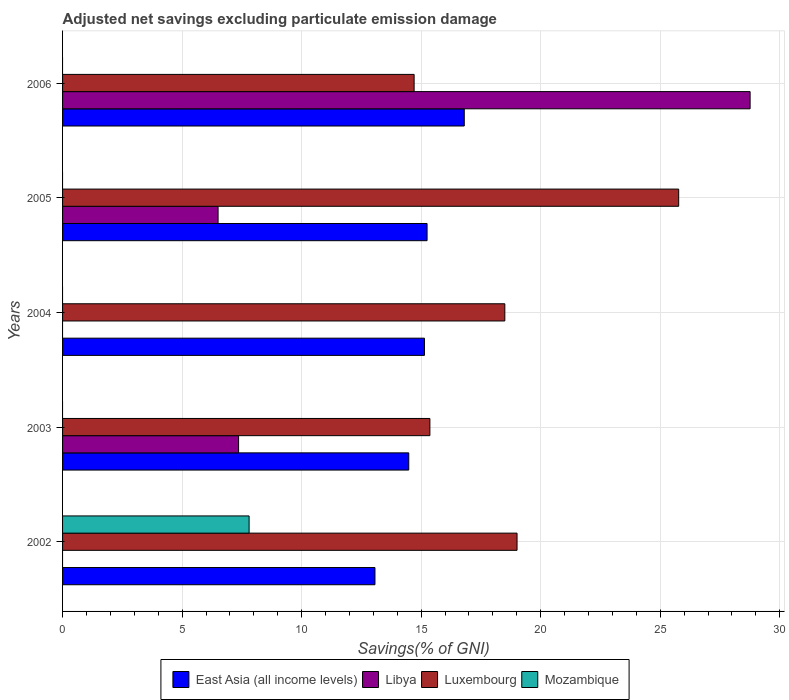How many different coloured bars are there?
Your answer should be compact. 4. How many groups of bars are there?
Your answer should be very brief. 5. Are the number of bars per tick equal to the number of legend labels?
Offer a very short reply. No. How many bars are there on the 3rd tick from the top?
Offer a terse response. 2. How many bars are there on the 4th tick from the bottom?
Your response must be concise. 3. In how many cases, is the number of bars for a given year not equal to the number of legend labels?
Your response must be concise. 5. What is the adjusted net savings in Mozambique in 2002?
Your answer should be very brief. 7.8. Across all years, what is the maximum adjusted net savings in Luxembourg?
Offer a terse response. 25.77. Across all years, what is the minimum adjusted net savings in Mozambique?
Offer a very short reply. 0. In which year was the adjusted net savings in Luxembourg maximum?
Offer a terse response. 2005. What is the total adjusted net savings in East Asia (all income levels) in the graph?
Offer a terse response. 74.74. What is the difference between the adjusted net savings in Libya in 2003 and that in 2006?
Give a very brief answer. -21.4. What is the difference between the adjusted net savings in Luxembourg in 2005 and the adjusted net savings in Libya in 2002?
Your answer should be compact. 25.77. What is the average adjusted net savings in East Asia (all income levels) per year?
Give a very brief answer. 14.95. In the year 2003, what is the difference between the adjusted net savings in East Asia (all income levels) and adjusted net savings in Luxembourg?
Give a very brief answer. -0.88. What is the ratio of the adjusted net savings in East Asia (all income levels) in 2005 to that in 2006?
Your answer should be compact. 0.91. Is the adjusted net savings in East Asia (all income levels) in 2003 less than that in 2004?
Make the answer very short. Yes. Is the difference between the adjusted net savings in East Asia (all income levels) in 2005 and 2006 greater than the difference between the adjusted net savings in Luxembourg in 2005 and 2006?
Make the answer very short. No. What is the difference between the highest and the second highest adjusted net savings in Libya?
Provide a short and direct response. 21.4. What is the difference between the highest and the lowest adjusted net savings in East Asia (all income levels)?
Your response must be concise. 3.74. Is the sum of the adjusted net savings in East Asia (all income levels) in 2003 and 2005 greater than the maximum adjusted net savings in Luxembourg across all years?
Your response must be concise. Yes. Is it the case that in every year, the sum of the adjusted net savings in East Asia (all income levels) and adjusted net savings in Luxembourg is greater than the adjusted net savings in Libya?
Keep it short and to the point. Yes. How many bars are there?
Offer a very short reply. 14. Are all the bars in the graph horizontal?
Provide a short and direct response. Yes. What is the difference between two consecutive major ticks on the X-axis?
Your response must be concise. 5. Does the graph contain any zero values?
Make the answer very short. Yes. Where does the legend appear in the graph?
Give a very brief answer. Bottom center. How are the legend labels stacked?
Your response must be concise. Horizontal. What is the title of the graph?
Keep it short and to the point. Adjusted net savings excluding particulate emission damage. Does "Gambia, The" appear as one of the legend labels in the graph?
Offer a terse response. No. What is the label or title of the X-axis?
Keep it short and to the point. Savings(% of GNI). What is the Savings(% of GNI) of East Asia (all income levels) in 2002?
Offer a terse response. 13.07. What is the Savings(% of GNI) in Libya in 2002?
Ensure brevity in your answer.  0. What is the Savings(% of GNI) in Luxembourg in 2002?
Keep it short and to the point. 19.01. What is the Savings(% of GNI) in Mozambique in 2002?
Offer a terse response. 7.8. What is the Savings(% of GNI) of East Asia (all income levels) in 2003?
Keep it short and to the point. 14.48. What is the Savings(% of GNI) of Libya in 2003?
Keep it short and to the point. 7.36. What is the Savings(% of GNI) in Luxembourg in 2003?
Ensure brevity in your answer.  15.36. What is the Savings(% of GNI) of Mozambique in 2003?
Your answer should be very brief. 0. What is the Savings(% of GNI) of East Asia (all income levels) in 2004?
Your answer should be very brief. 15.14. What is the Savings(% of GNI) of Libya in 2004?
Provide a short and direct response. 0. What is the Savings(% of GNI) of Luxembourg in 2004?
Ensure brevity in your answer.  18.5. What is the Savings(% of GNI) of East Asia (all income levels) in 2005?
Your response must be concise. 15.25. What is the Savings(% of GNI) of Libya in 2005?
Your response must be concise. 6.51. What is the Savings(% of GNI) in Luxembourg in 2005?
Provide a short and direct response. 25.77. What is the Savings(% of GNI) in East Asia (all income levels) in 2006?
Ensure brevity in your answer.  16.8. What is the Savings(% of GNI) of Libya in 2006?
Your answer should be compact. 28.76. What is the Savings(% of GNI) in Luxembourg in 2006?
Your response must be concise. 14.71. Across all years, what is the maximum Savings(% of GNI) in East Asia (all income levels)?
Ensure brevity in your answer.  16.8. Across all years, what is the maximum Savings(% of GNI) of Libya?
Ensure brevity in your answer.  28.76. Across all years, what is the maximum Savings(% of GNI) of Luxembourg?
Provide a short and direct response. 25.77. Across all years, what is the maximum Savings(% of GNI) of Mozambique?
Your answer should be compact. 7.8. Across all years, what is the minimum Savings(% of GNI) in East Asia (all income levels)?
Provide a short and direct response. 13.07. Across all years, what is the minimum Savings(% of GNI) in Libya?
Make the answer very short. 0. Across all years, what is the minimum Savings(% of GNI) of Luxembourg?
Offer a terse response. 14.71. Across all years, what is the minimum Savings(% of GNI) in Mozambique?
Provide a short and direct response. 0. What is the total Savings(% of GNI) of East Asia (all income levels) in the graph?
Keep it short and to the point. 74.74. What is the total Savings(% of GNI) of Libya in the graph?
Offer a terse response. 42.63. What is the total Savings(% of GNI) of Luxembourg in the graph?
Offer a very short reply. 93.35. What is the total Savings(% of GNI) in Mozambique in the graph?
Offer a very short reply. 7.8. What is the difference between the Savings(% of GNI) in East Asia (all income levels) in 2002 and that in 2003?
Keep it short and to the point. -1.41. What is the difference between the Savings(% of GNI) in Luxembourg in 2002 and that in 2003?
Offer a terse response. 3.65. What is the difference between the Savings(% of GNI) in East Asia (all income levels) in 2002 and that in 2004?
Make the answer very short. -2.07. What is the difference between the Savings(% of GNI) of Luxembourg in 2002 and that in 2004?
Your answer should be very brief. 0.51. What is the difference between the Savings(% of GNI) in East Asia (all income levels) in 2002 and that in 2005?
Provide a succinct answer. -2.18. What is the difference between the Savings(% of GNI) in Luxembourg in 2002 and that in 2005?
Your answer should be compact. -6.76. What is the difference between the Savings(% of GNI) in East Asia (all income levels) in 2002 and that in 2006?
Make the answer very short. -3.74. What is the difference between the Savings(% of GNI) of Luxembourg in 2002 and that in 2006?
Offer a terse response. 4.31. What is the difference between the Savings(% of GNI) of East Asia (all income levels) in 2003 and that in 2004?
Keep it short and to the point. -0.66. What is the difference between the Savings(% of GNI) of Luxembourg in 2003 and that in 2004?
Your response must be concise. -3.13. What is the difference between the Savings(% of GNI) of East Asia (all income levels) in 2003 and that in 2005?
Your answer should be very brief. -0.77. What is the difference between the Savings(% of GNI) in Libya in 2003 and that in 2005?
Provide a short and direct response. 0.86. What is the difference between the Savings(% of GNI) in Luxembourg in 2003 and that in 2005?
Make the answer very short. -10.41. What is the difference between the Savings(% of GNI) of East Asia (all income levels) in 2003 and that in 2006?
Provide a short and direct response. -2.32. What is the difference between the Savings(% of GNI) in Libya in 2003 and that in 2006?
Give a very brief answer. -21.4. What is the difference between the Savings(% of GNI) in Luxembourg in 2003 and that in 2006?
Keep it short and to the point. 0.66. What is the difference between the Savings(% of GNI) of East Asia (all income levels) in 2004 and that in 2005?
Give a very brief answer. -0.11. What is the difference between the Savings(% of GNI) in Luxembourg in 2004 and that in 2005?
Offer a very short reply. -7.27. What is the difference between the Savings(% of GNI) in East Asia (all income levels) in 2004 and that in 2006?
Keep it short and to the point. -1.66. What is the difference between the Savings(% of GNI) of Luxembourg in 2004 and that in 2006?
Offer a terse response. 3.79. What is the difference between the Savings(% of GNI) of East Asia (all income levels) in 2005 and that in 2006?
Make the answer very short. -1.56. What is the difference between the Savings(% of GNI) in Libya in 2005 and that in 2006?
Keep it short and to the point. -22.25. What is the difference between the Savings(% of GNI) of Luxembourg in 2005 and that in 2006?
Make the answer very short. 11.07. What is the difference between the Savings(% of GNI) in East Asia (all income levels) in 2002 and the Savings(% of GNI) in Libya in 2003?
Offer a very short reply. 5.7. What is the difference between the Savings(% of GNI) of East Asia (all income levels) in 2002 and the Savings(% of GNI) of Luxembourg in 2003?
Provide a succinct answer. -2.3. What is the difference between the Savings(% of GNI) of East Asia (all income levels) in 2002 and the Savings(% of GNI) of Luxembourg in 2004?
Give a very brief answer. -5.43. What is the difference between the Savings(% of GNI) of East Asia (all income levels) in 2002 and the Savings(% of GNI) of Libya in 2005?
Ensure brevity in your answer.  6.56. What is the difference between the Savings(% of GNI) of East Asia (all income levels) in 2002 and the Savings(% of GNI) of Luxembourg in 2005?
Give a very brief answer. -12.7. What is the difference between the Savings(% of GNI) in East Asia (all income levels) in 2002 and the Savings(% of GNI) in Libya in 2006?
Keep it short and to the point. -15.69. What is the difference between the Savings(% of GNI) in East Asia (all income levels) in 2002 and the Savings(% of GNI) in Luxembourg in 2006?
Keep it short and to the point. -1.64. What is the difference between the Savings(% of GNI) of East Asia (all income levels) in 2003 and the Savings(% of GNI) of Luxembourg in 2004?
Make the answer very short. -4.02. What is the difference between the Savings(% of GNI) of Libya in 2003 and the Savings(% of GNI) of Luxembourg in 2004?
Your response must be concise. -11.14. What is the difference between the Savings(% of GNI) in East Asia (all income levels) in 2003 and the Savings(% of GNI) in Libya in 2005?
Offer a terse response. 7.98. What is the difference between the Savings(% of GNI) of East Asia (all income levels) in 2003 and the Savings(% of GNI) of Luxembourg in 2005?
Your answer should be very brief. -11.29. What is the difference between the Savings(% of GNI) of Libya in 2003 and the Savings(% of GNI) of Luxembourg in 2005?
Keep it short and to the point. -18.41. What is the difference between the Savings(% of GNI) in East Asia (all income levels) in 2003 and the Savings(% of GNI) in Libya in 2006?
Ensure brevity in your answer.  -14.28. What is the difference between the Savings(% of GNI) of East Asia (all income levels) in 2003 and the Savings(% of GNI) of Luxembourg in 2006?
Your response must be concise. -0.22. What is the difference between the Savings(% of GNI) in Libya in 2003 and the Savings(% of GNI) in Luxembourg in 2006?
Keep it short and to the point. -7.34. What is the difference between the Savings(% of GNI) of East Asia (all income levels) in 2004 and the Savings(% of GNI) of Libya in 2005?
Ensure brevity in your answer.  8.63. What is the difference between the Savings(% of GNI) of East Asia (all income levels) in 2004 and the Savings(% of GNI) of Luxembourg in 2005?
Provide a short and direct response. -10.63. What is the difference between the Savings(% of GNI) in East Asia (all income levels) in 2004 and the Savings(% of GNI) in Libya in 2006?
Your answer should be compact. -13.62. What is the difference between the Savings(% of GNI) of East Asia (all income levels) in 2004 and the Savings(% of GNI) of Luxembourg in 2006?
Provide a short and direct response. 0.43. What is the difference between the Savings(% of GNI) in East Asia (all income levels) in 2005 and the Savings(% of GNI) in Libya in 2006?
Offer a very short reply. -13.51. What is the difference between the Savings(% of GNI) in East Asia (all income levels) in 2005 and the Savings(% of GNI) in Luxembourg in 2006?
Provide a short and direct response. 0.54. What is the difference between the Savings(% of GNI) in Libya in 2005 and the Savings(% of GNI) in Luxembourg in 2006?
Make the answer very short. -8.2. What is the average Savings(% of GNI) of East Asia (all income levels) per year?
Offer a terse response. 14.95. What is the average Savings(% of GNI) in Libya per year?
Ensure brevity in your answer.  8.53. What is the average Savings(% of GNI) of Luxembourg per year?
Offer a terse response. 18.67. What is the average Savings(% of GNI) of Mozambique per year?
Your answer should be compact. 1.56. In the year 2002, what is the difference between the Savings(% of GNI) in East Asia (all income levels) and Savings(% of GNI) in Luxembourg?
Offer a very short reply. -5.94. In the year 2002, what is the difference between the Savings(% of GNI) of East Asia (all income levels) and Savings(% of GNI) of Mozambique?
Ensure brevity in your answer.  5.26. In the year 2002, what is the difference between the Savings(% of GNI) in Luxembourg and Savings(% of GNI) in Mozambique?
Ensure brevity in your answer.  11.21. In the year 2003, what is the difference between the Savings(% of GNI) in East Asia (all income levels) and Savings(% of GNI) in Libya?
Keep it short and to the point. 7.12. In the year 2003, what is the difference between the Savings(% of GNI) in East Asia (all income levels) and Savings(% of GNI) in Luxembourg?
Your answer should be compact. -0.88. In the year 2003, what is the difference between the Savings(% of GNI) in Libya and Savings(% of GNI) in Luxembourg?
Your response must be concise. -8. In the year 2004, what is the difference between the Savings(% of GNI) in East Asia (all income levels) and Savings(% of GNI) in Luxembourg?
Make the answer very short. -3.36. In the year 2005, what is the difference between the Savings(% of GNI) of East Asia (all income levels) and Savings(% of GNI) of Libya?
Provide a short and direct response. 8.74. In the year 2005, what is the difference between the Savings(% of GNI) of East Asia (all income levels) and Savings(% of GNI) of Luxembourg?
Your answer should be compact. -10.52. In the year 2005, what is the difference between the Savings(% of GNI) in Libya and Savings(% of GNI) in Luxembourg?
Keep it short and to the point. -19.27. In the year 2006, what is the difference between the Savings(% of GNI) of East Asia (all income levels) and Savings(% of GNI) of Libya?
Make the answer very short. -11.96. In the year 2006, what is the difference between the Savings(% of GNI) in East Asia (all income levels) and Savings(% of GNI) in Luxembourg?
Provide a succinct answer. 2.1. In the year 2006, what is the difference between the Savings(% of GNI) of Libya and Savings(% of GNI) of Luxembourg?
Offer a very short reply. 14.05. What is the ratio of the Savings(% of GNI) in East Asia (all income levels) in 2002 to that in 2003?
Give a very brief answer. 0.9. What is the ratio of the Savings(% of GNI) in Luxembourg in 2002 to that in 2003?
Make the answer very short. 1.24. What is the ratio of the Savings(% of GNI) in East Asia (all income levels) in 2002 to that in 2004?
Offer a very short reply. 0.86. What is the ratio of the Savings(% of GNI) of Luxembourg in 2002 to that in 2004?
Your answer should be very brief. 1.03. What is the ratio of the Savings(% of GNI) of East Asia (all income levels) in 2002 to that in 2005?
Provide a succinct answer. 0.86. What is the ratio of the Savings(% of GNI) of Luxembourg in 2002 to that in 2005?
Your response must be concise. 0.74. What is the ratio of the Savings(% of GNI) of East Asia (all income levels) in 2002 to that in 2006?
Your answer should be compact. 0.78. What is the ratio of the Savings(% of GNI) in Luxembourg in 2002 to that in 2006?
Give a very brief answer. 1.29. What is the ratio of the Savings(% of GNI) in East Asia (all income levels) in 2003 to that in 2004?
Your answer should be compact. 0.96. What is the ratio of the Savings(% of GNI) of Luxembourg in 2003 to that in 2004?
Ensure brevity in your answer.  0.83. What is the ratio of the Savings(% of GNI) of East Asia (all income levels) in 2003 to that in 2005?
Provide a short and direct response. 0.95. What is the ratio of the Savings(% of GNI) of Libya in 2003 to that in 2005?
Provide a short and direct response. 1.13. What is the ratio of the Savings(% of GNI) of Luxembourg in 2003 to that in 2005?
Your answer should be compact. 0.6. What is the ratio of the Savings(% of GNI) of East Asia (all income levels) in 2003 to that in 2006?
Give a very brief answer. 0.86. What is the ratio of the Savings(% of GNI) of Libya in 2003 to that in 2006?
Your answer should be very brief. 0.26. What is the ratio of the Savings(% of GNI) of Luxembourg in 2003 to that in 2006?
Provide a short and direct response. 1.04. What is the ratio of the Savings(% of GNI) in East Asia (all income levels) in 2004 to that in 2005?
Your answer should be compact. 0.99. What is the ratio of the Savings(% of GNI) of Luxembourg in 2004 to that in 2005?
Keep it short and to the point. 0.72. What is the ratio of the Savings(% of GNI) of East Asia (all income levels) in 2004 to that in 2006?
Your answer should be compact. 0.9. What is the ratio of the Savings(% of GNI) of Luxembourg in 2004 to that in 2006?
Give a very brief answer. 1.26. What is the ratio of the Savings(% of GNI) in East Asia (all income levels) in 2005 to that in 2006?
Offer a very short reply. 0.91. What is the ratio of the Savings(% of GNI) of Libya in 2005 to that in 2006?
Give a very brief answer. 0.23. What is the ratio of the Savings(% of GNI) in Luxembourg in 2005 to that in 2006?
Make the answer very short. 1.75. What is the difference between the highest and the second highest Savings(% of GNI) in East Asia (all income levels)?
Your answer should be compact. 1.56. What is the difference between the highest and the second highest Savings(% of GNI) of Libya?
Give a very brief answer. 21.4. What is the difference between the highest and the second highest Savings(% of GNI) in Luxembourg?
Your answer should be compact. 6.76. What is the difference between the highest and the lowest Savings(% of GNI) in East Asia (all income levels)?
Offer a terse response. 3.74. What is the difference between the highest and the lowest Savings(% of GNI) in Libya?
Provide a succinct answer. 28.76. What is the difference between the highest and the lowest Savings(% of GNI) of Luxembourg?
Make the answer very short. 11.07. What is the difference between the highest and the lowest Savings(% of GNI) in Mozambique?
Provide a short and direct response. 7.8. 